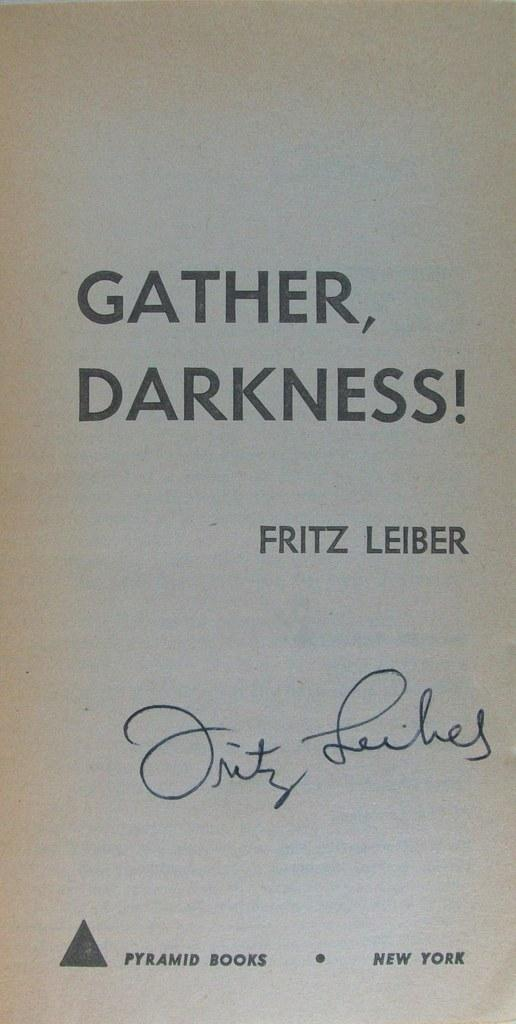<image>
Describe the image concisely. A cover page for the book gather, darkness by Fritz Leiber. 